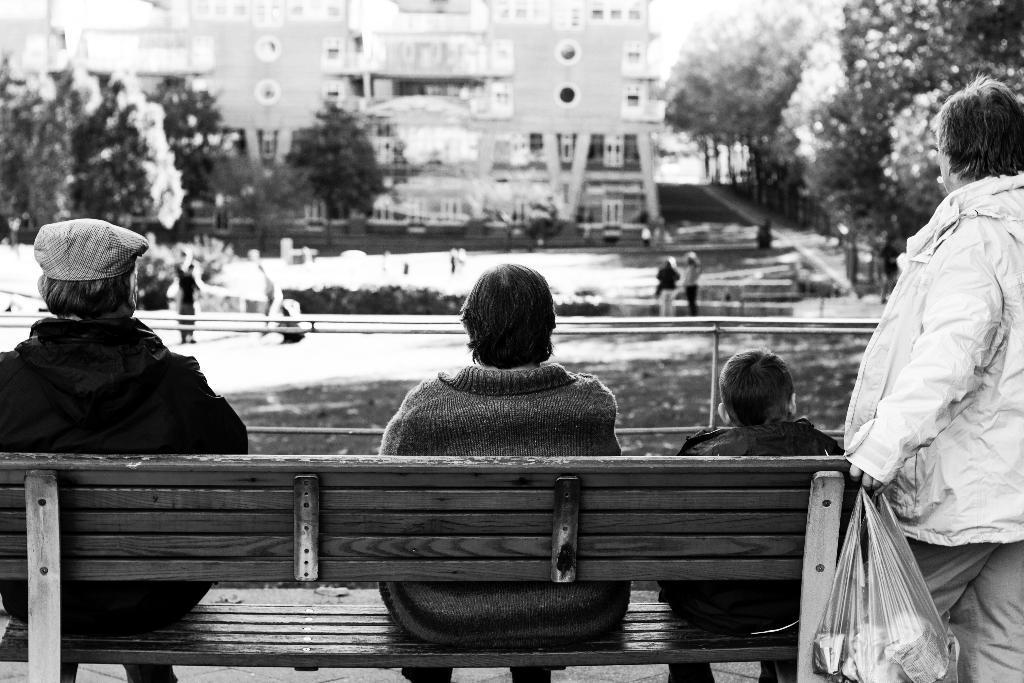Can you describe this image briefly? This is a black and white picture. In Front of the picture we can see three persons sitting on a bench. Beside to them there is one person standing and holding a carry bag in hand. On the background we can see building, trees and few persons walking and standing. 